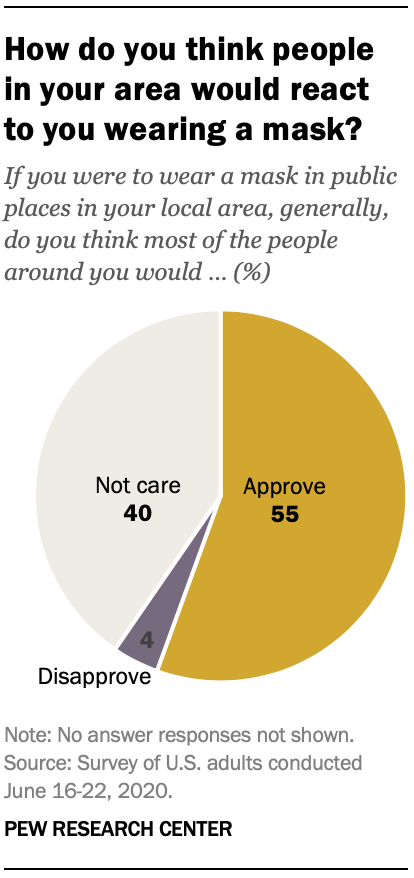Outline some significant characteristics in this image. The larger of the two largest segments is greater than the smaller of the two smallest segments. The color of the largest segment is orange. 